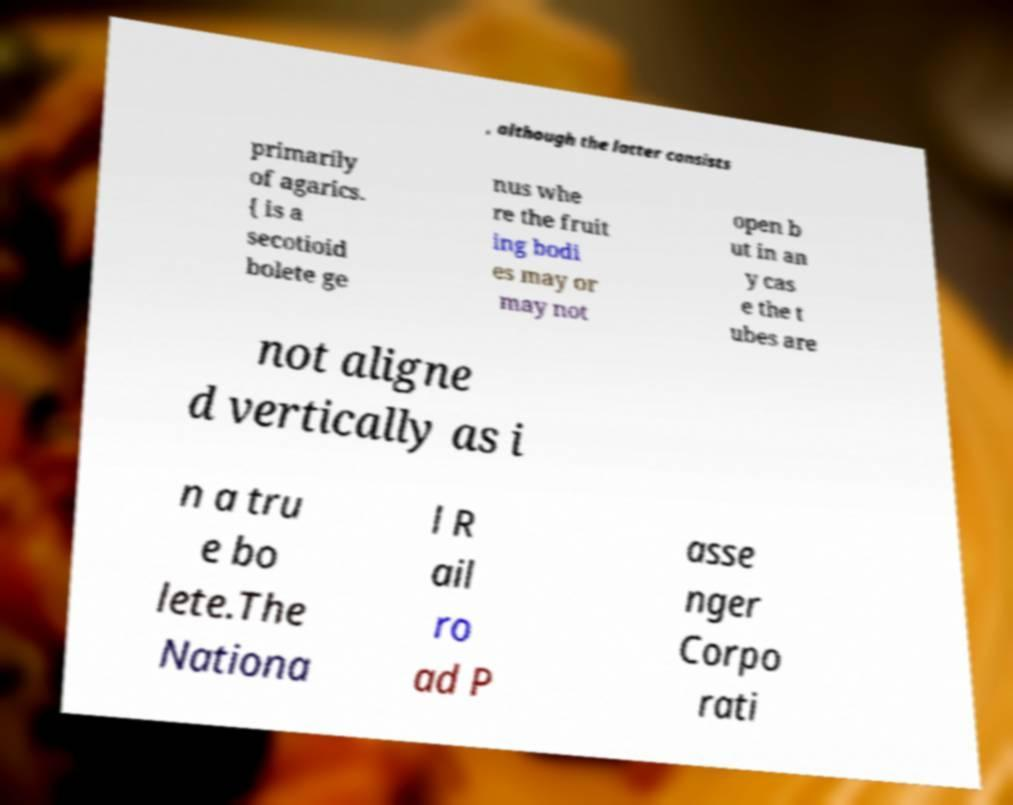What messages or text are displayed in this image? I need them in a readable, typed format. , although the latter consists primarily of agarics. { is a secotioid bolete ge nus whe re the fruit ing bodi es may or may not open b ut in an y cas e the t ubes are not aligne d vertically as i n a tru e bo lete.The Nationa l R ail ro ad P asse nger Corpo rati 